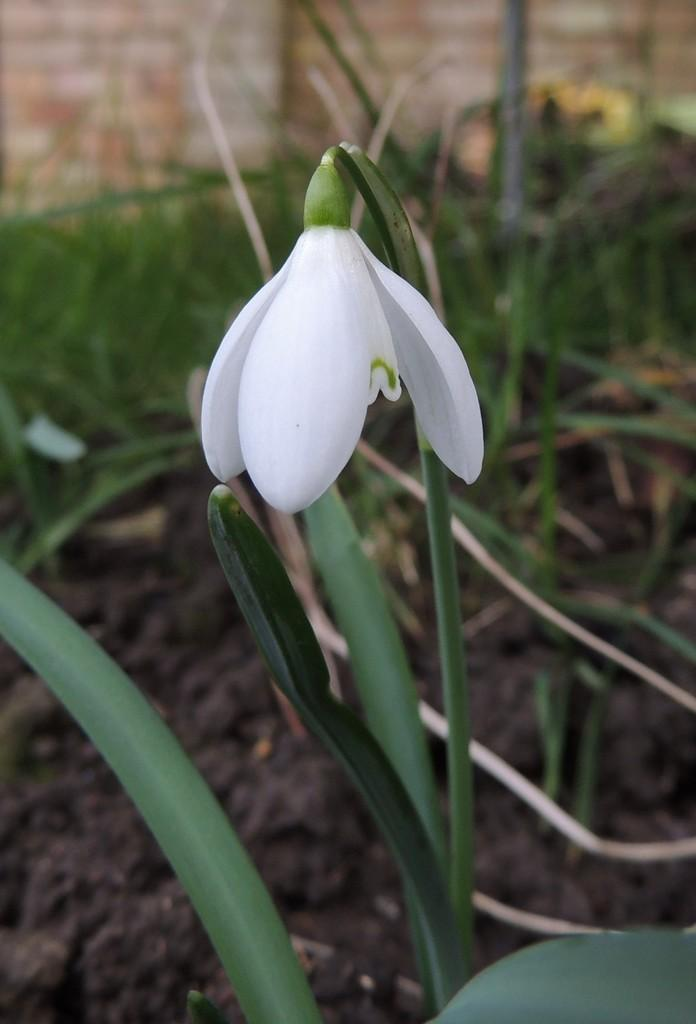What type of plant is featured in the image? There is a plant with a white flower in the image. What can be seen in the background of the image? Soil, grass, and a wall are visible in the background of the image. How many cows are visible in the image? There are no cows present in the image. What type of nerve can be seen in the image? There is no nerve visible in the image; it features a plant with a white flower and a background with soil, grass, and a wall. 